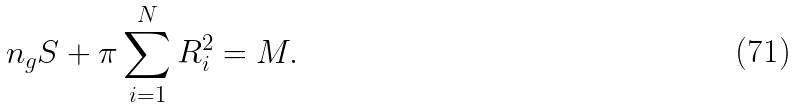Convert formula to latex. <formula><loc_0><loc_0><loc_500><loc_500>n _ { g } S + \pi \sum _ { i = 1 } ^ { N } R _ { i } ^ { 2 } = M .</formula> 